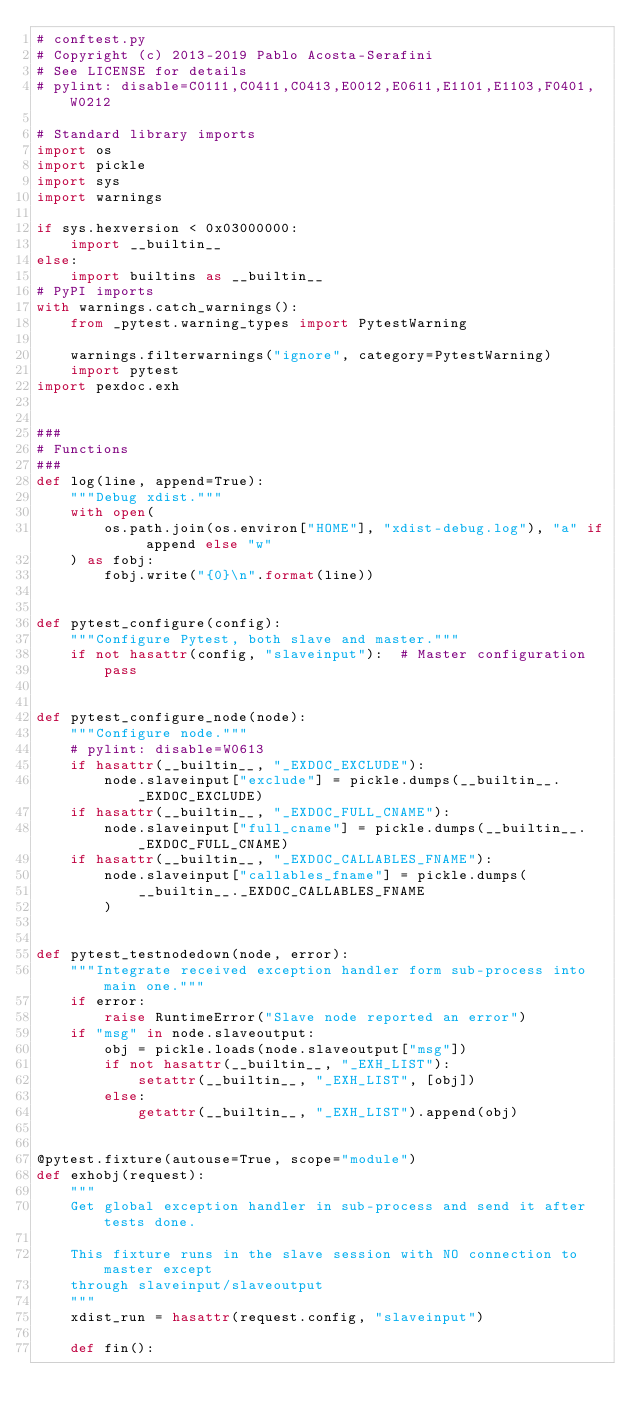<code> <loc_0><loc_0><loc_500><loc_500><_Python_># conftest.py
# Copyright (c) 2013-2019 Pablo Acosta-Serafini
# See LICENSE for details
# pylint: disable=C0111,C0411,C0413,E0012,E0611,E1101,E1103,F0401,W0212

# Standard library imports
import os
import pickle
import sys
import warnings

if sys.hexversion < 0x03000000:
    import __builtin__
else:
    import builtins as __builtin__
# PyPI imports
with warnings.catch_warnings():
    from _pytest.warning_types import PytestWarning

    warnings.filterwarnings("ignore", category=PytestWarning)
    import pytest
import pexdoc.exh


###
# Functions
###
def log(line, append=True):
    """Debug xdist."""
    with open(
        os.path.join(os.environ["HOME"], "xdist-debug.log"), "a" if append else "w"
    ) as fobj:
        fobj.write("{0}\n".format(line))


def pytest_configure(config):
    """Configure Pytest, both slave and master."""
    if not hasattr(config, "slaveinput"):  # Master configuration
        pass


def pytest_configure_node(node):
    """Configure node."""
    # pylint: disable=W0613
    if hasattr(__builtin__, "_EXDOC_EXCLUDE"):
        node.slaveinput["exclude"] = pickle.dumps(__builtin__._EXDOC_EXCLUDE)
    if hasattr(__builtin__, "_EXDOC_FULL_CNAME"):
        node.slaveinput["full_cname"] = pickle.dumps(__builtin__._EXDOC_FULL_CNAME)
    if hasattr(__builtin__, "_EXDOC_CALLABLES_FNAME"):
        node.slaveinput["callables_fname"] = pickle.dumps(
            __builtin__._EXDOC_CALLABLES_FNAME
        )


def pytest_testnodedown(node, error):
    """Integrate received exception handler form sub-process into main one."""
    if error:
        raise RuntimeError("Slave node reported an error")
    if "msg" in node.slaveoutput:
        obj = pickle.loads(node.slaveoutput["msg"])
        if not hasattr(__builtin__, "_EXH_LIST"):
            setattr(__builtin__, "_EXH_LIST", [obj])
        else:
            getattr(__builtin__, "_EXH_LIST").append(obj)


@pytest.fixture(autouse=True, scope="module")
def exhobj(request):
    """
    Get global exception handler in sub-process and send it after tests done.

    This fixture runs in the slave session with NO connection to master except
    through slaveinput/slaveoutput
    """
    xdist_run = hasattr(request.config, "slaveinput")

    def fin():</code> 